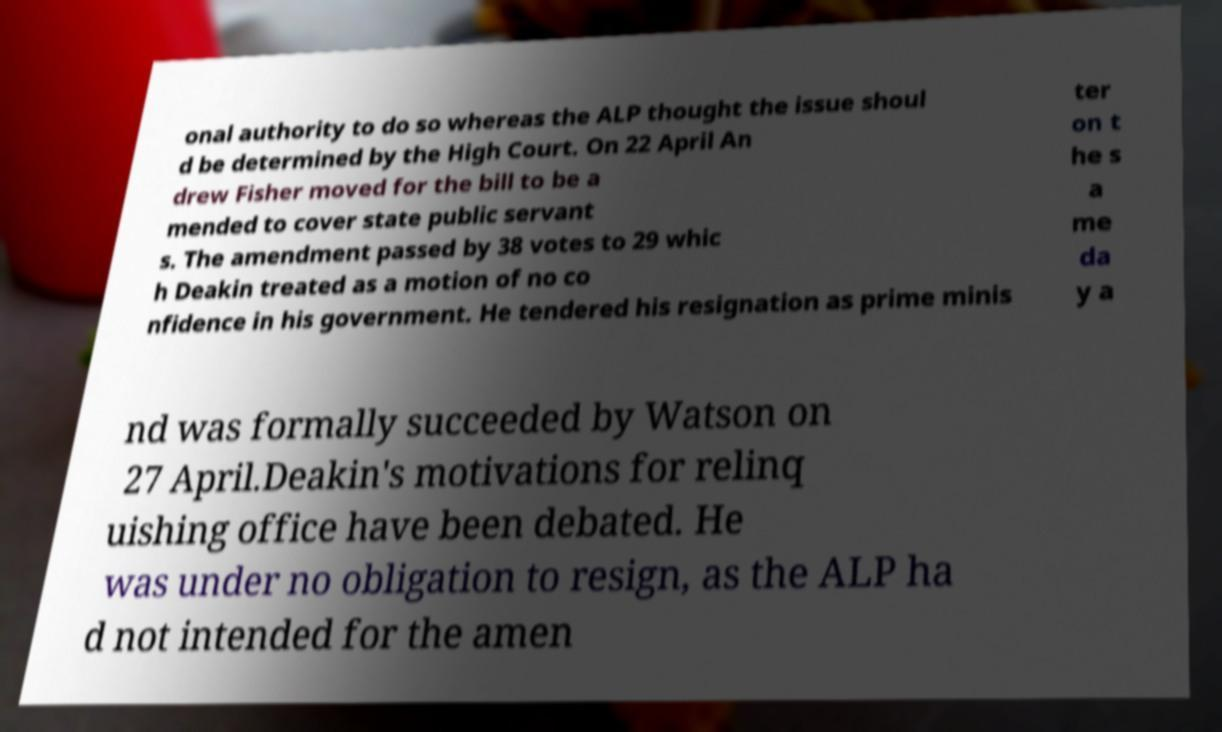For documentation purposes, I need the text within this image transcribed. Could you provide that? onal authority to do so whereas the ALP thought the issue shoul d be determined by the High Court. On 22 April An drew Fisher moved for the bill to be a mended to cover state public servant s. The amendment passed by 38 votes to 29 whic h Deakin treated as a motion of no co nfidence in his government. He tendered his resignation as prime minis ter on t he s a me da y a nd was formally succeeded by Watson on 27 April.Deakin's motivations for relinq uishing office have been debated. He was under no obligation to resign, as the ALP ha d not intended for the amen 